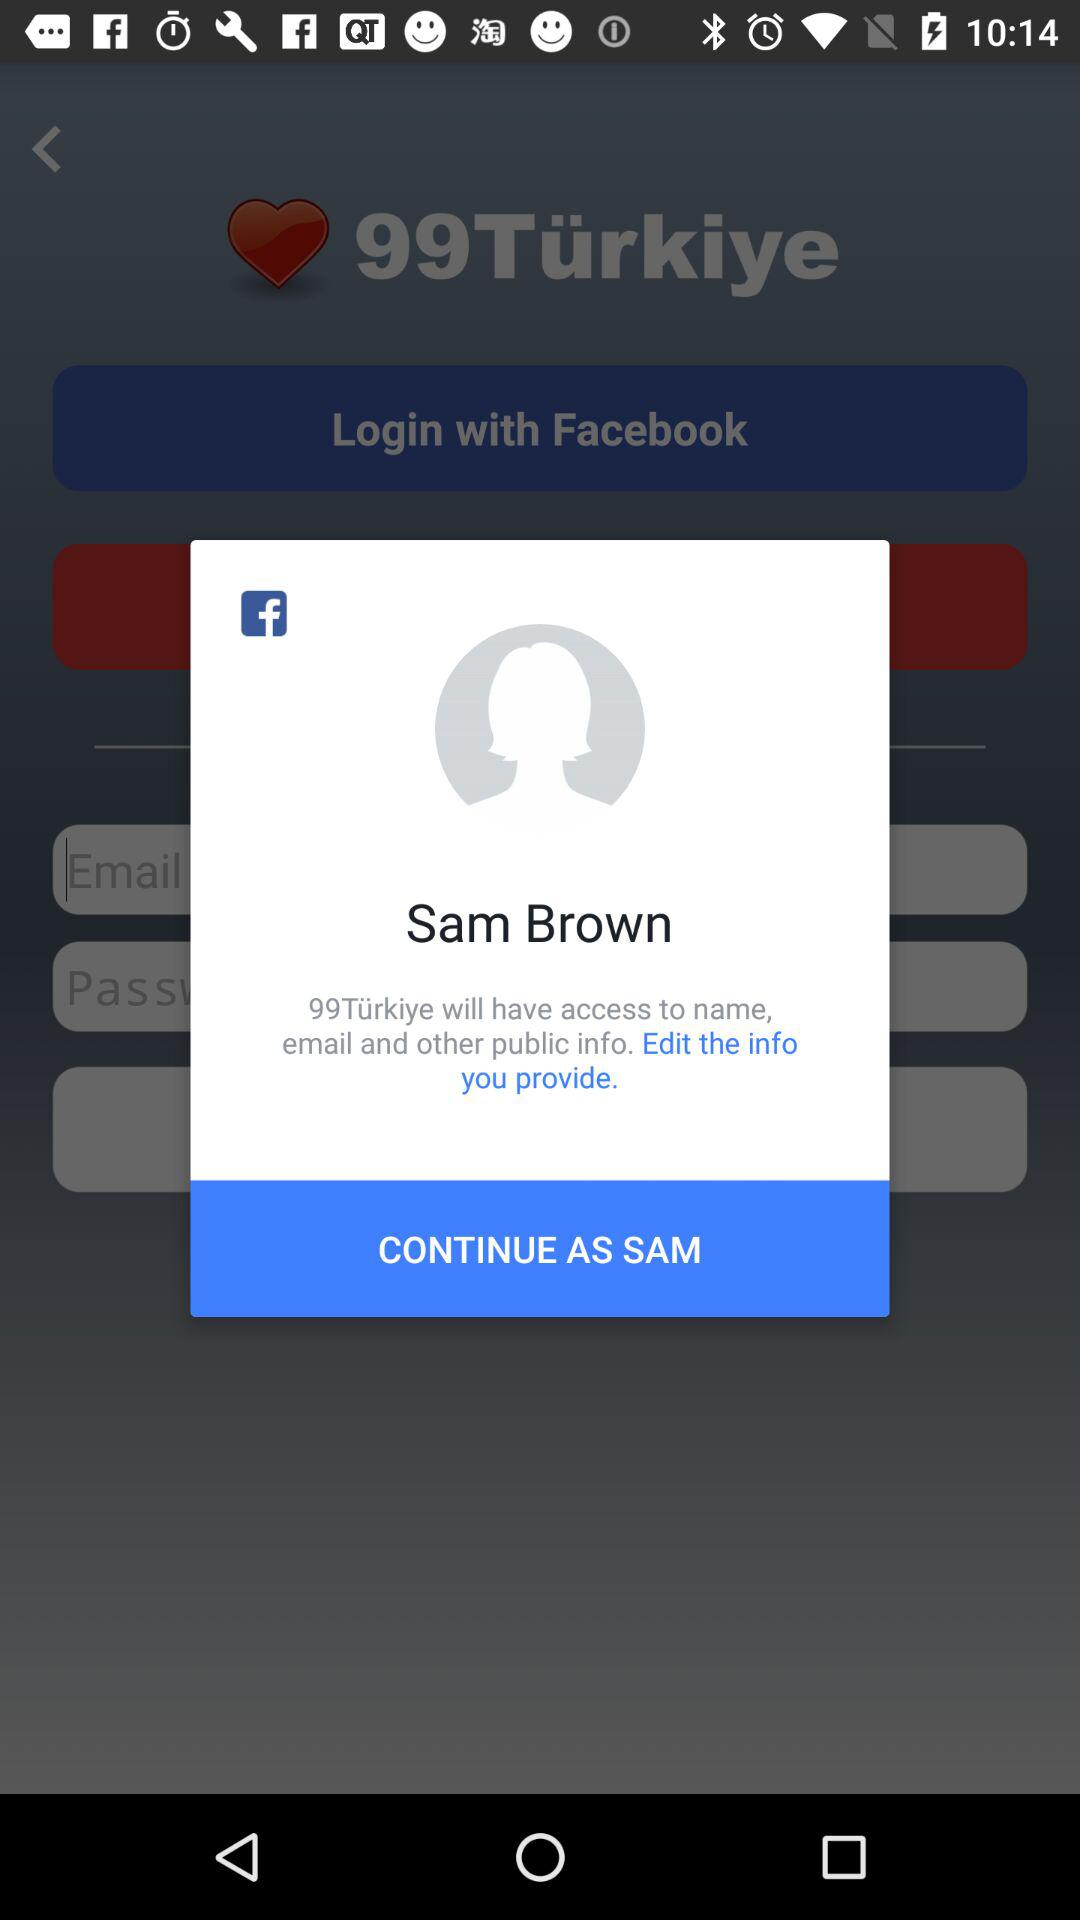Through what account can logging in be done? Logging in can be done through "Facebook". 